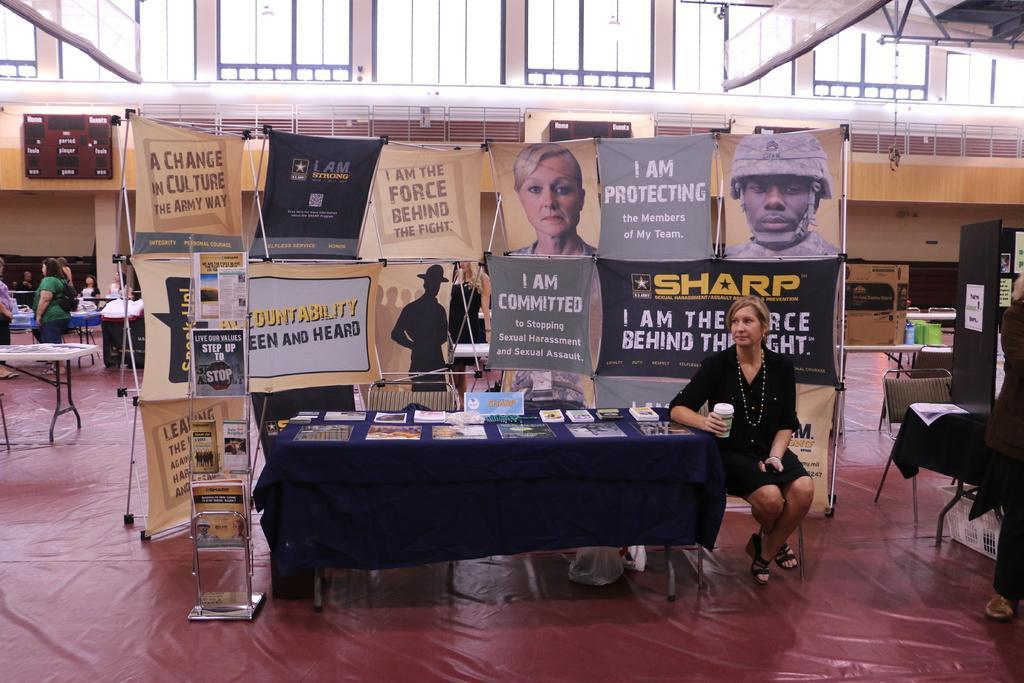Please provide a concise description of this image. In this picture we can see a woman sitting on the chair. This is table. On the table there are books. This is floor. Here we can see some persons. And these are the banners. 